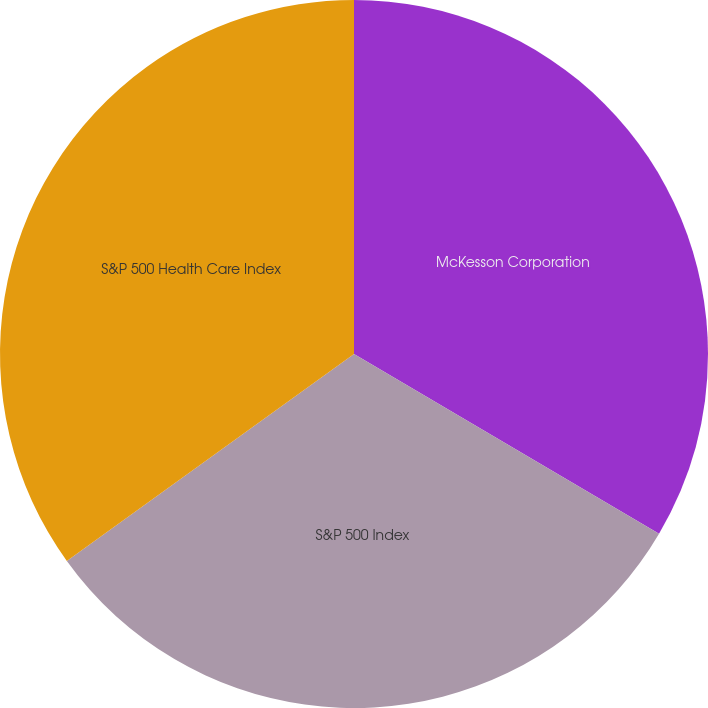Convert chart. <chart><loc_0><loc_0><loc_500><loc_500><pie_chart><fcel>McKesson Corporation<fcel>S&P 500 Index<fcel>S&P 500 Health Care Index<nl><fcel>33.47%<fcel>31.59%<fcel>34.94%<nl></chart> 